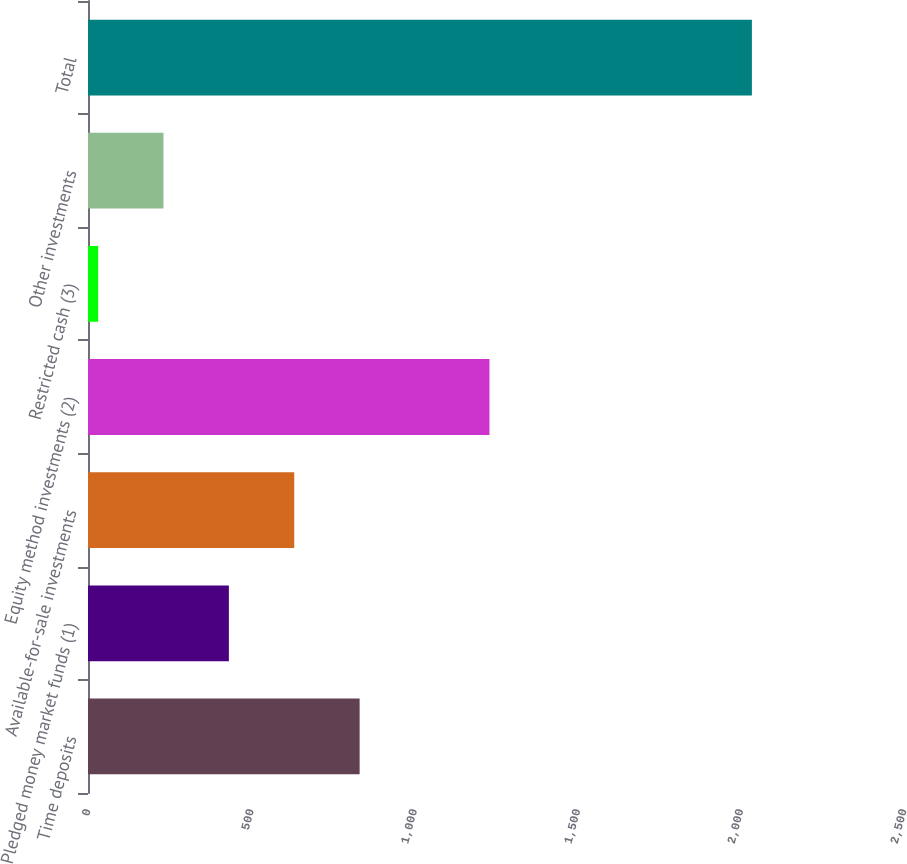Convert chart. <chart><loc_0><loc_0><loc_500><loc_500><bar_chart><fcel>Time deposits<fcel>Pledged money market funds (1)<fcel>Available-for-sale investments<fcel>Equity method investments (2)<fcel>Restricted cash (3)<fcel>Other investments<fcel>Total<nl><fcel>832.2<fcel>431.6<fcel>631.9<fcel>1230<fcel>31<fcel>231.3<fcel>2034<nl></chart> 